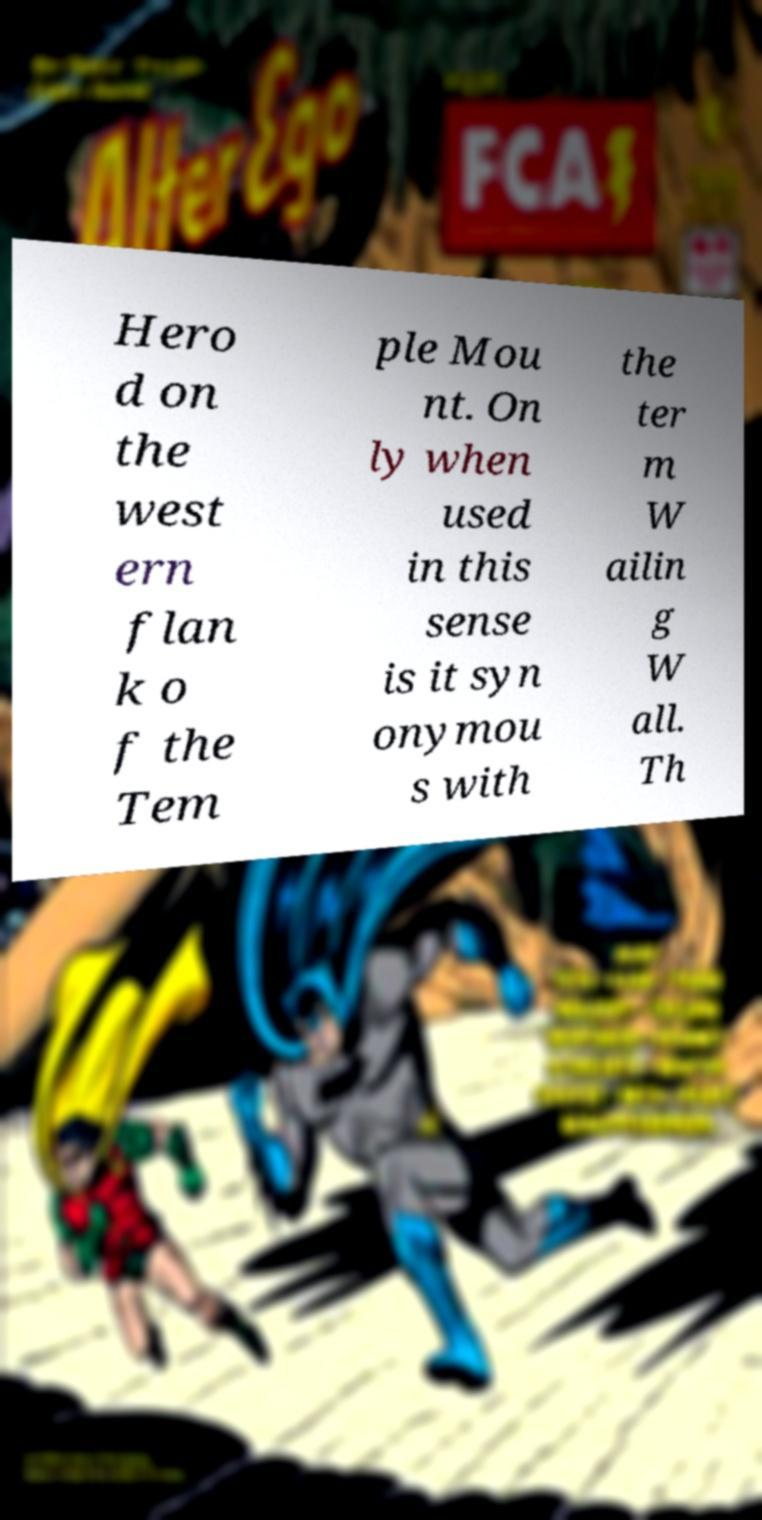Can you accurately transcribe the text from the provided image for me? Hero d on the west ern flan k o f the Tem ple Mou nt. On ly when used in this sense is it syn onymou s with the ter m W ailin g W all. Th 